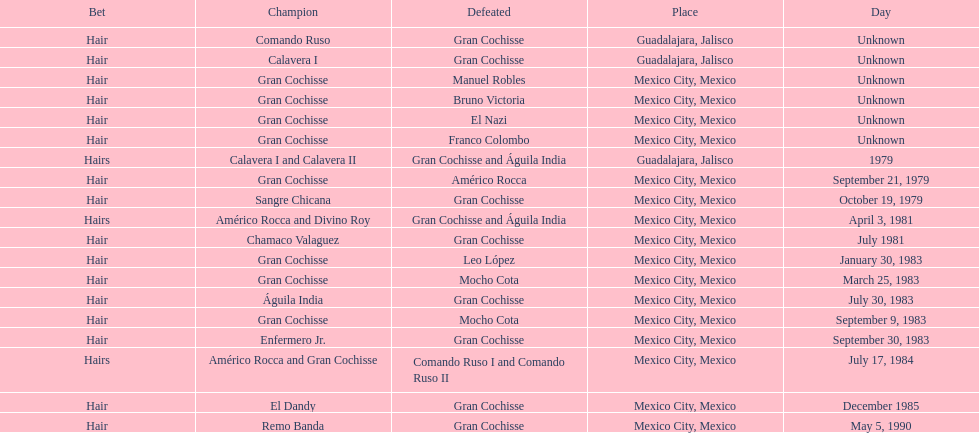Would you mind parsing the complete table? {'header': ['Bet', 'Champion', 'Defeated', 'Place', 'Day'], 'rows': [['Hair', 'Comando Ruso', 'Gran Cochisse', 'Guadalajara, Jalisco', 'Unknown'], ['Hair', 'Calavera I', 'Gran Cochisse', 'Guadalajara, Jalisco', 'Unknown'], ['Hair', 'Gran Cochisse', 'Manuel Robles', 'Mexico City, Mexico', 'Unknown'], ['Hair', 'Gran Cochisse', 'Bruno Victoria', 'Mexico City, Mexico', 'Unknown'], ['Hair', 'Gran Cochisse', 'El Nazi', 'Mexico City, Mexico', 'Unknown'], ['Hair', 'Gran Cochisse', 'Franco Colombo', 'Mexico City, Mexico', 'Unknown'], ['Hairs', 'Calavera I and Calavera II', 'Gran Cochisse and Águila India', 'Guadalajara, Jalisco', '1979'], ['Hair', 'Gran Cochisse', 'Américo Rocca', 'Mexico City, Mexico', 'September 21, 1979'], ['Hair', 'Sangre Chicana', 'Gran Cochisse', 'Mexico City, Mexico', 'October 19, 1979'], ['Hairs', 'Américo Rocca and Divino Roy', 'Gran Cochisse and Águila India', 'Mexico City, Mexico', 'April 3, 1981'], ['Hair', 'Chamaco Valaguez', 'Gran Cochisse', 'Mexico City, Mexico', 'July 1981'], ['Hair', 'Gran Cochisse', 'Leo López', 'Mexico City, Mexico', 'January 30, 1983'], ['Hair', 'Gran Cochisse', 'Mocho Cota', 'Mexico City, Mexico', 'March 25, 1983'], ['Hair', 'Águila India', 'Gran Cochisse', 'Mexico City, Mexico', 'July 30, 1983'], ['Hair', 'Gran Cochisse', 'Mocho Cota', 'Mexico City, Mexico', 'September 9, 1983'], ['Hair', 'Enfermero Jr.', 'Gran Cochisse', 'Mexico City, Mexico', 'September 30, 1983'], ['Hairs', 'Américo Rocca and Gran Cochisse', 'Comando Ruso I and Comando Ruso II', 'Mexico City, Mexico', 'July 17, 1984'], ['Hair', 'El Dandy', 'Gran Cochisse', 'Mexico City, Mexico', 'December 1985'], ['Hair', 'Remo Banda', 'Gran Cochisse', 'Mexico City, Mexico', 'May 5, 1990']]} How many times has gran cochisse been a winner? 9. 